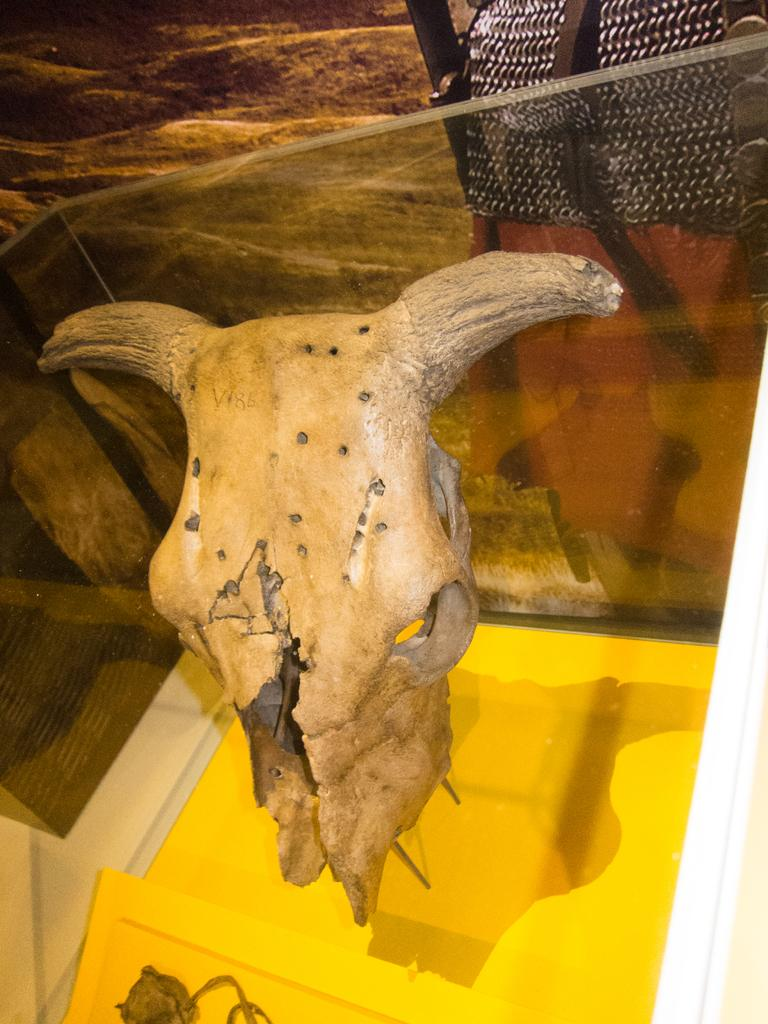What is the main subject of the image? The main subject of the image is a skull of an animal with two horns. How is the skull displayed in the image? The skull is placed in a glass box. What color is the base in the image? The base in the image has a yellow color. What can be seen in the background of the image? There is a yellow color wall in the background of the image. What is the price of the jeans worn by the animal in the image? There are no jeans or animals wearing them present in the image. 